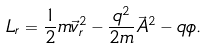<formula> <loc_0><loc_0><loc_500><loc_500>L _ { r } = \frac { 1 } { 2 } m \vec { v } _ { r } ^ { 2 } - \frac { q ^ { 2 } } { 2 m } \vec { A } ^ { 2 } - q \phi .</formula> 